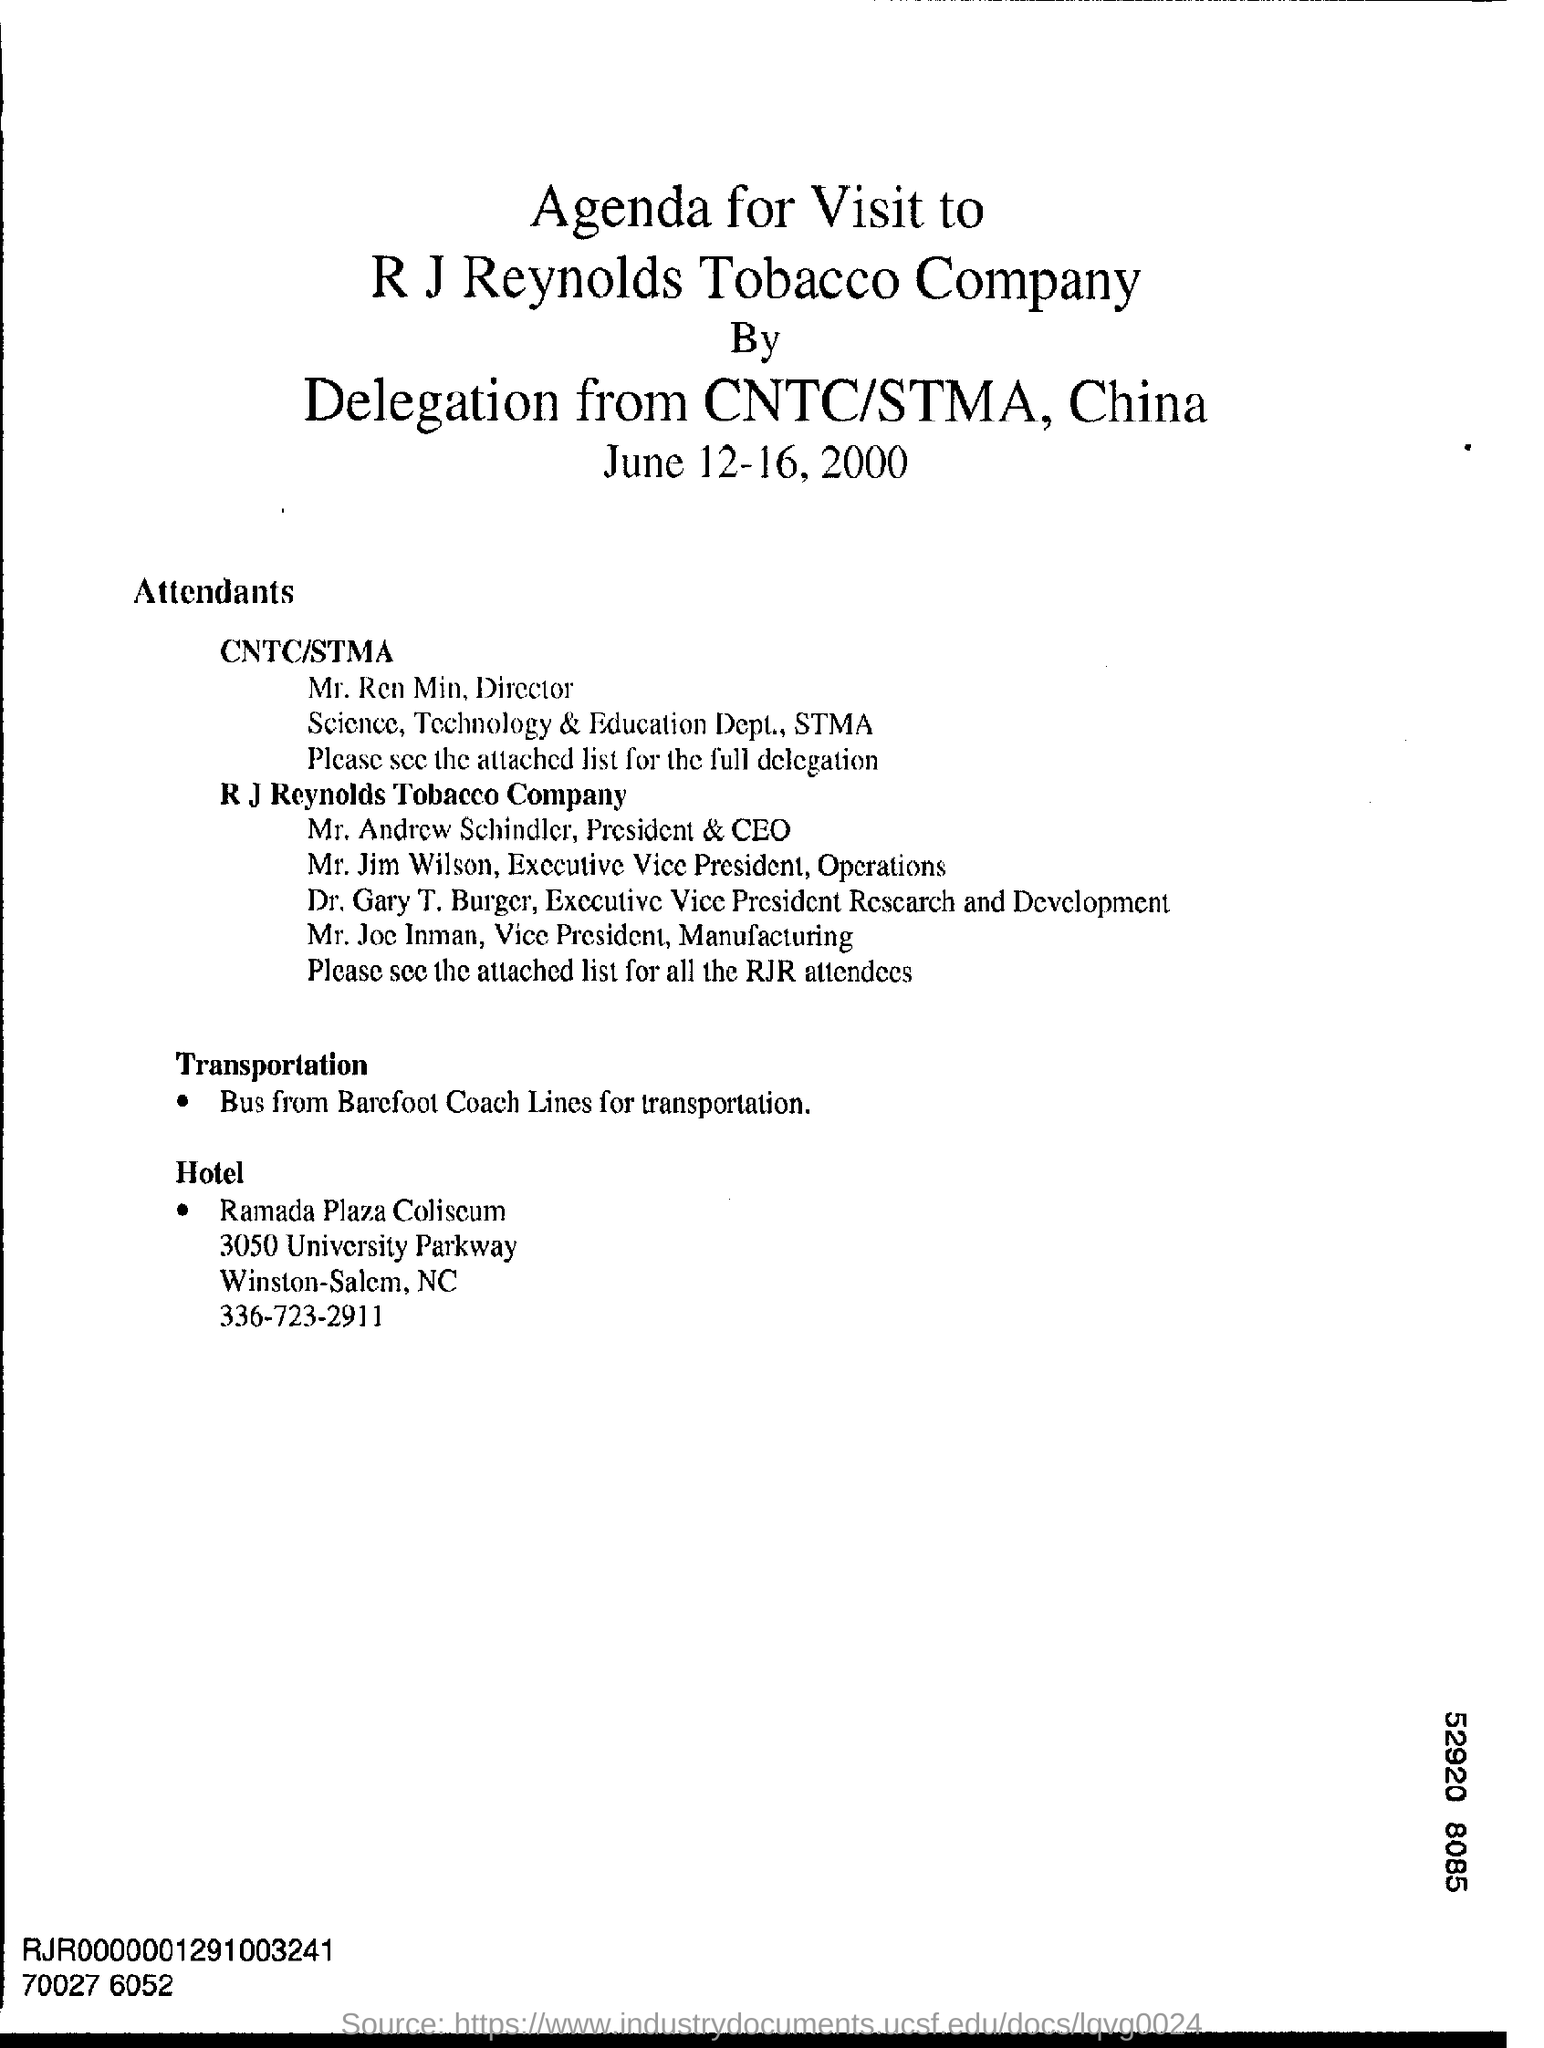Identify some key points in this picture. Mr. Andrew Schindler holds the position of President and CEO. The individual known as Mr. Joe Inman is the Vice President of Manufacturing for the R.J. Reynolds Tobacco Company. Ramada Plaza Coliseum can be found in the state of North Carolina. R.J. Reynolds Tobacco Company is the name of a tobacco company. The delegation is from CNTC/STMA in China. 